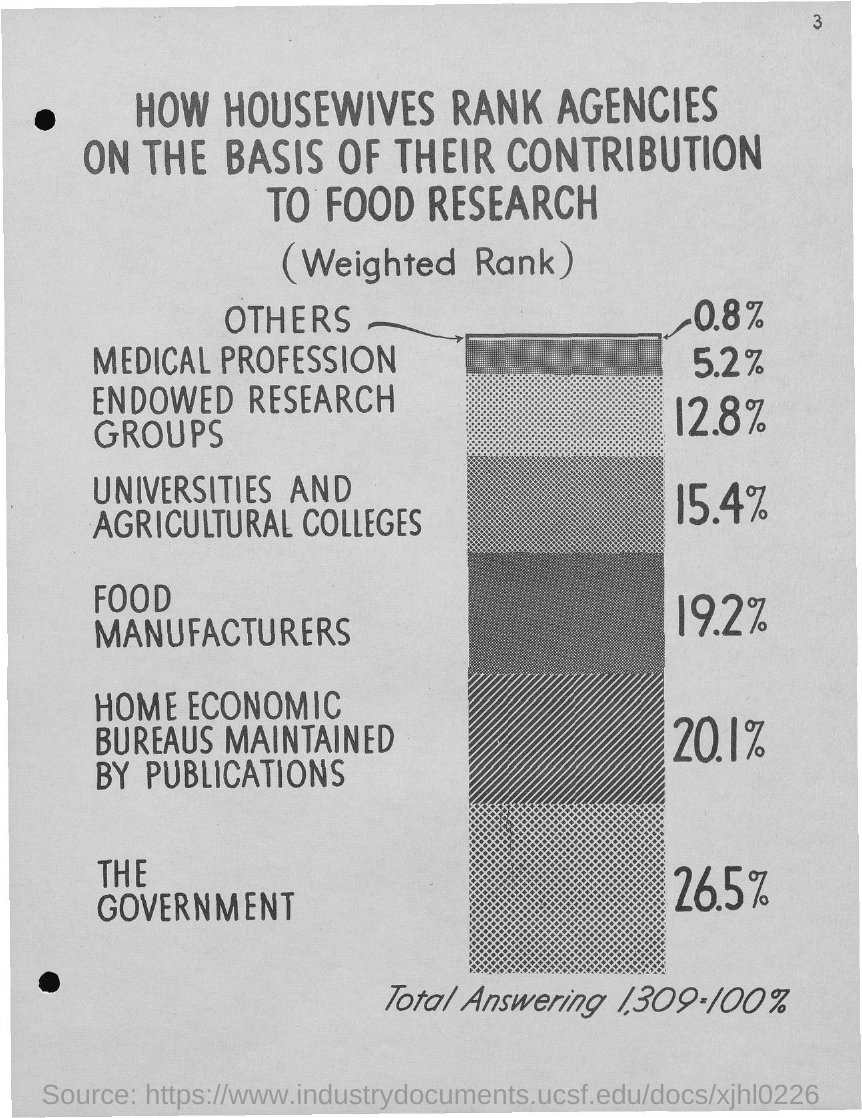What is the page number?
Your response must be concise. 3. What is the title of the document?
Your response must be concise. HOW HOUSEWIVES RANK AGENCIES ON THE BASIS OF THEIR CONTRIBUTION TO FOOD RESEARCH. Which agency ranks first in their contribution to food research?
Offer a very short reply. THE GOVERNMENT. Which agency ranks least in their contribution to food research?
Your answer should be very brief. OTHERS. Which agency ranks second in their contribution to food research?
Make the answer very short. Home Economic bureaus maintained by publications. 